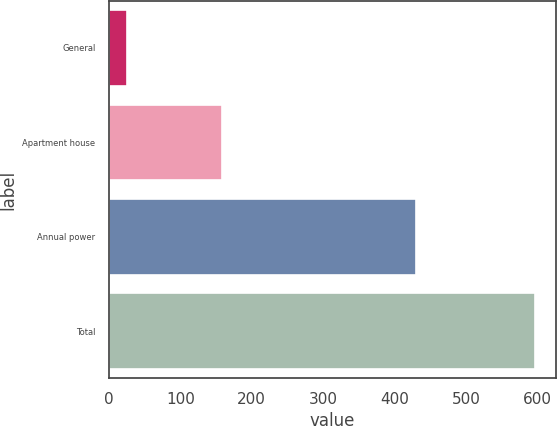Convert chart to OTSL. <chart><loc_0><loc_0><loc_500><loc_500><bar_chart><fcel>General<fcel>Apartment house<fcel>Annual power<fcel>Total<nl><fcel>25<fcel>158<fcel>429<fcel>596<nl></chart> 